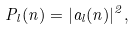Convert formula to latex. <formula><loc_0><loc_0><loc_500><loc_500>P _ { l } ( n ) = | a _ { l } ( n ) | ^ { 2 } ,</formula> 